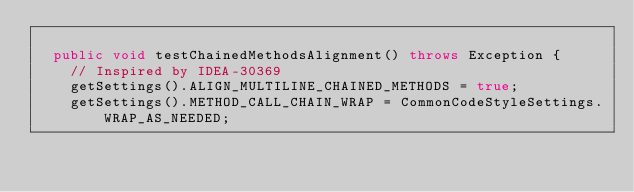Convert code to text. <code><loc_0><loc_0><loc_500><loc_500><_Java_>
  public void testChainedMethodsAlignment() throws Exception {
    // Inspired by IDEA-30369
    getSettings().ALIGN_MULTILINE_CHAINED_METHODS = true;
    getSettings().METHOD_CALL_CHAIN_WRAP = CommonCodeStyleSettings.WRAP_AS_NEEDED;</code> 